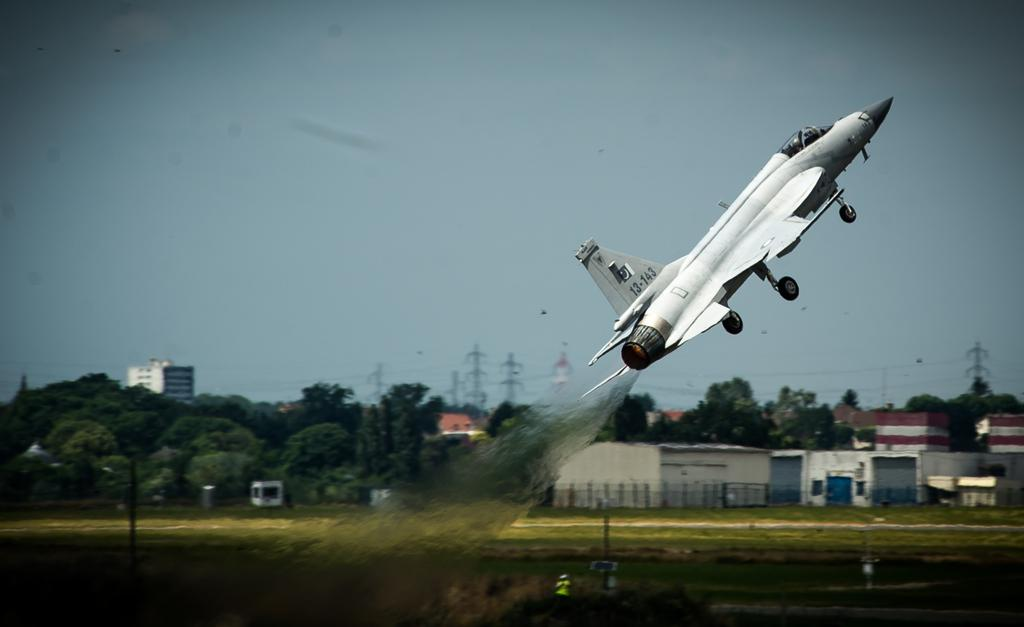<image>
Describe the image concisely. a jet plane taking off with numbers 13-143 on the tail fin 